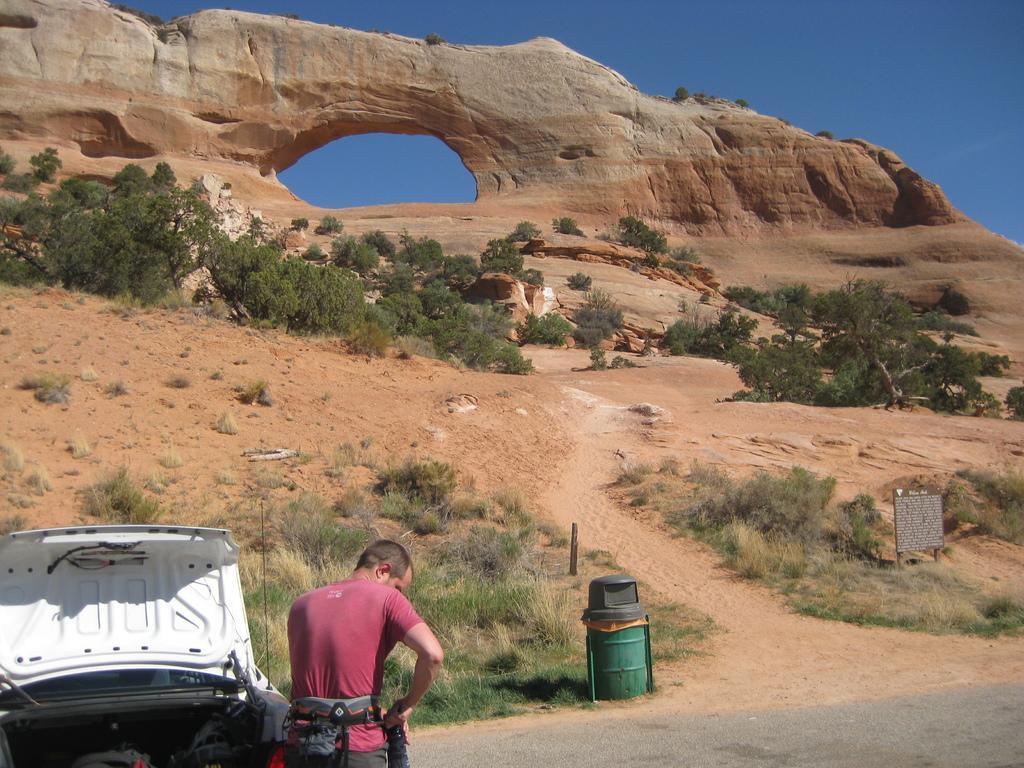In one or two sentences, can you explain what this image depicts? At the bottom of the image there is a man standing, next to him there is a vehicle. In the center there is a bin. In the background we can see an arch, trees, board and sky. 